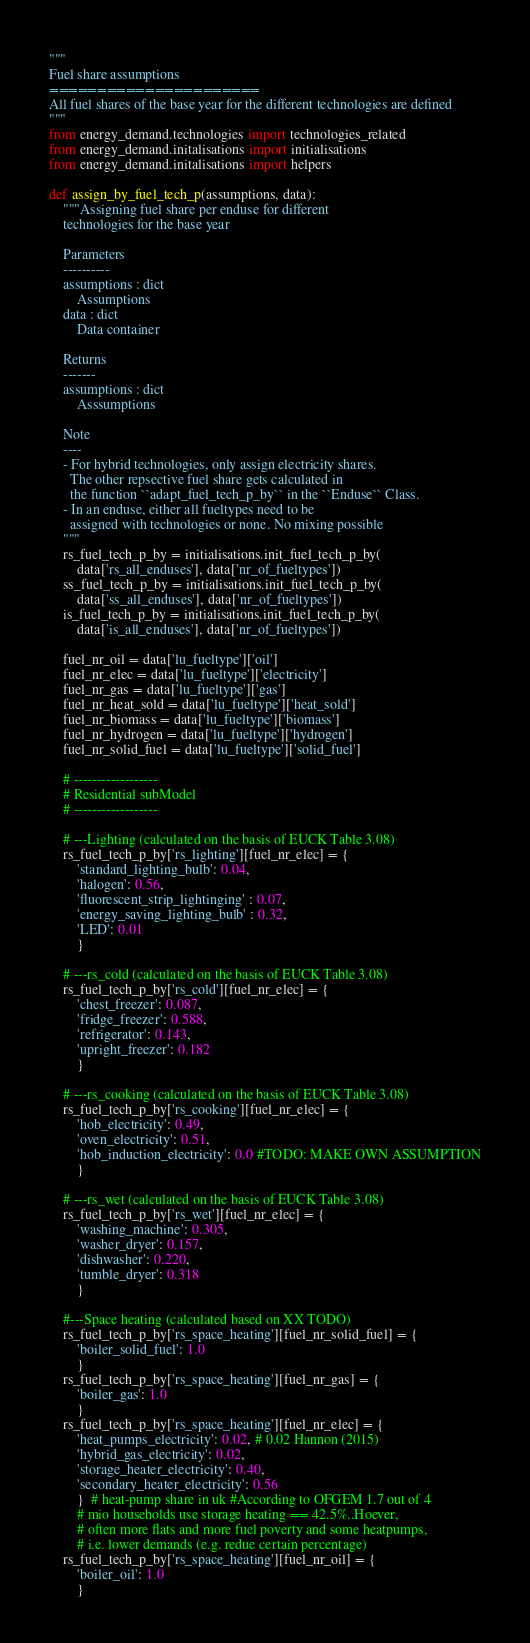<code> <loc_0><loc_0><loc_500><loc_500><_Python_>"""
Fuel share assumptions
======================
All fuel shares of the base year for the different technologies are defined
"""
from energy_demand.technologies import technologies_related
from energy_demand.initalisations import initialisations
from energy_demand.initalisations import helpers

def assign_by_fuel_tech_p(assumptions, data):
    """Assigning fuel share per enduse for different
    technologies for the base year

    Parameters
    ----------
    assumptions : dict
        Assumptions
    data : dict
        Data container

    Returns
    -------
    assumptions : dict
        Asssumptions

    Note
    ----
    - For hybrid technologies, only assign electricity shares.
      The other repsective fuel share gets calculated in
      the function ``adapt_fuel_tech_p_by`` in the ``Enduse`` Class.
    - In an enduse, either all fueltypes need to be
      assigned with technologies or none. No mixing possible
    """
    rs_fuel_tech_p_by = initialisations.init_fuel_tech_p_by(
        data['rs_all_enduses'], data['nr_of_fueltypes'])
    ss_fuel_tech_p_by = initialisations.init_fuel_tech_p_by(
        data['ss_all_enduses'], data['nr_of_fueltypes'])
    is_fuel_tech_p_by = initialisations.init_fuel_tech_p_by(
        data['is_all_enduses'], data['nr_of_fueltypes'])

    fuel_nr_oil = data['lu_fueltype']['oil']
    fuel_nr_elec = data['lu_fueltype']['electricity']
    fuel_nr_gas = data['lu_fueltype']['gas']
    fuel_nr_heat_sold = data['lu_fueltype']['heat_sold']
    fuel_nr_biomass = data['lu_fueltype']['biomass']
    fuel_nr_hydrogen = data['lu_fueltype']['hydrogen']
    fuel_nr_solid_fuel = data['lu_fueltype']['solid_fuel']

    # ------------------
    # Residential subModel
    # ------------------

    # ---Lighting (calculated on the basis of EUCK Table 3.08)
    rs_fuel_tech_p_by['rs_lighting'][fuel_nr_elec] = {
        'standard_lighting_bulb': 0.04,
        'halogen': 0.56,
        'fluorescent_strip_lightinging' : 0.07,
        'energy_saving_lighting_bulb' : 0.32,
        'LED': 0.01
        }

    # ---rs_cold (calculated on the basis of EUCK Table 3.08)
    rs_fuel_tech_p_by['rs_cold'][fuel_nr_elec] = {
        'chest_freezer': 0.087,
        'fridge_freezer': 0.588,
        'refrigerator': 0.143,
        'upright_freezer': 0.182
        }

    # ---rs_cooking (calculated on the basis of EUCK Table 3.08)
    rs_fuel_tech_p_by['rs_cooking'][fuel_nr_elec] = {
        'hob_electricity': 0.49,
        'oven_electricity': 0.51,
        'hob_induction_electricity': 0.0 #TODO: MAKE OWN ASSUMPTION
        }

    # ---rs_wet (calculated on the basis of EUCK Table 3.08)
    rs_fuel_tech_p_by['rs_wet'][fuel_nr_elec] = {
        'washing_machine': 0.305,
        'washer_dryer': 0.157,
        'dishwasher': 0.220,
        'tumble_dryer': 0.318
        }

    #---Space heating (calculated based on XX TODO)
    rs_fuel_tech_p_by['rs_space_heating'][fuel_nr_solid_fuel] = {
        'boiler_solid_fuel': 1.0
        }
    rs_fuel_tech_p_by['rs_space_heating'][fuel_nr_gas] = {
        'boiler_gas': 1.0
        }
    rs_fuel_tech_p_by['rs_space_heating'][fuel_nr_elec] = {
        'heat_pumps_electricity': 0.02, # 0.02 Hannon (2015)
        'hybrid_gas_electricity': 0.02,
        'storage_heater_electricity': 0.40,
        'secondary_heater_electricity': 0.56
        }  # heat-pump share in uk #According to OFGEM 1.7 out of 4
        # mio households use storage heating == 42.5%..Hoever,
        # often more flats and more fuel poverty and some heatpumps,
        # i.e. lower demands (e.g. redue certain percentage)
    rs_fuel_tech_p_by['rs_space_heating'][fuel_nr_oil] = {
        'boiler_oil': 1.0
        }</code> 